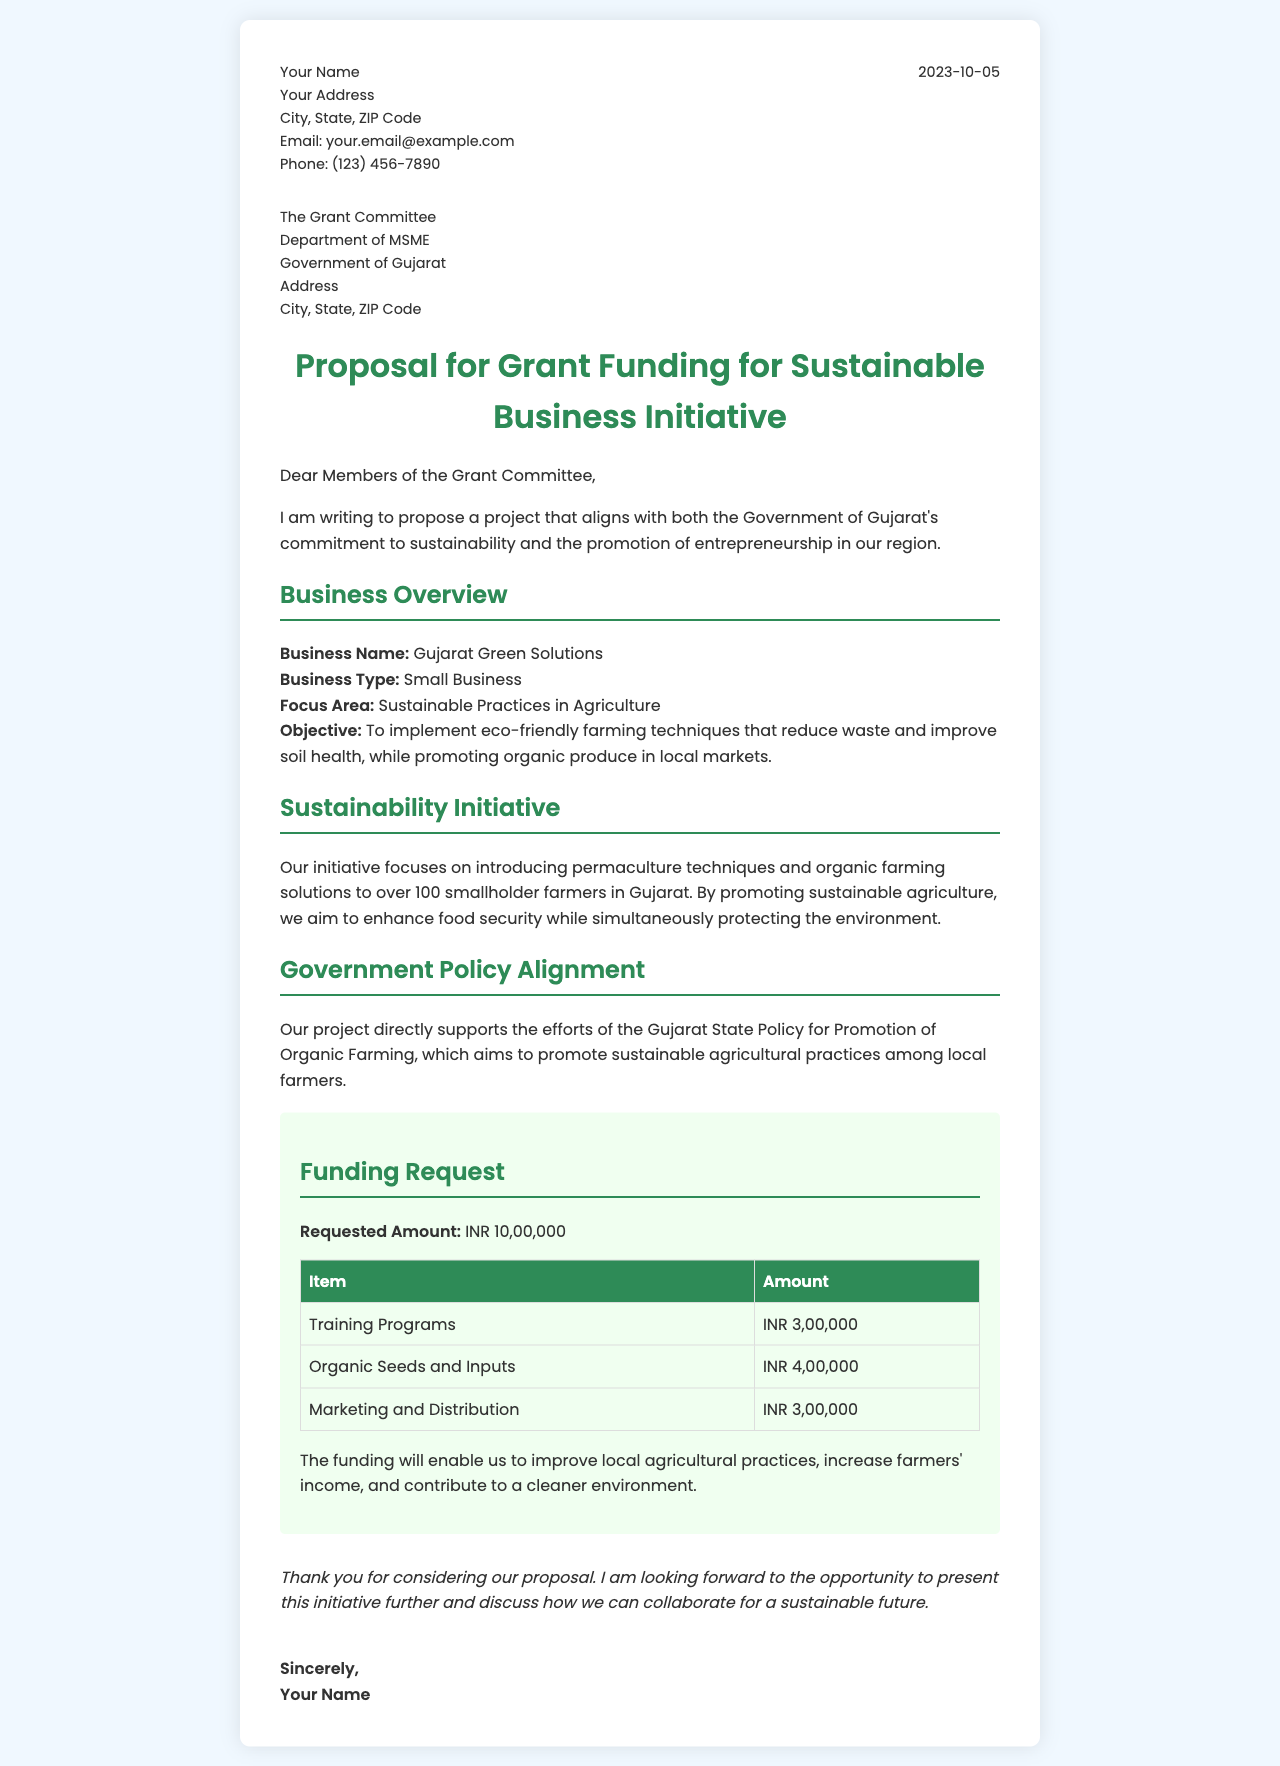What is the name of the business? The business name is mentioned in the document under the business overview section.
Answer: Gujarat Green Solutions What is the requested funding amount? The funding request section clearly states the amount being sought.
Answer: INR 10,00,000 What is the primary focus area of the project? The focus area is indicated in the business overview section.
Answer: Sustainable Practices in Agriculture Which government policy does the initiative align with? The document explicitly refers to a specific government policy in the government policy alignment section.
Answer: Gujarat State Policy for Promotion of Organic Farming How many smallholder farmers will benefit from the initiative? The number of farmers targeted is stated in the sustainability initiative section.
Answer: 100 What is the budget allocation for organic seeds and inputs? The funding request section provides specific amounts allocated for various items.
Answer: INR 4,00,000 What is the date of the letter? The date is found at the top of the letter, in the header section.
Answer: 2023-10-05 What type of business is Gujarat Green Solutions? The business type is categorized in the document under the business overview section.
Answer: Small Business What is the purpose of the training programs? The document implies the purpose in relation to improving agricultural practices based on the funding request.
Answer: To improve local agricultural practices 